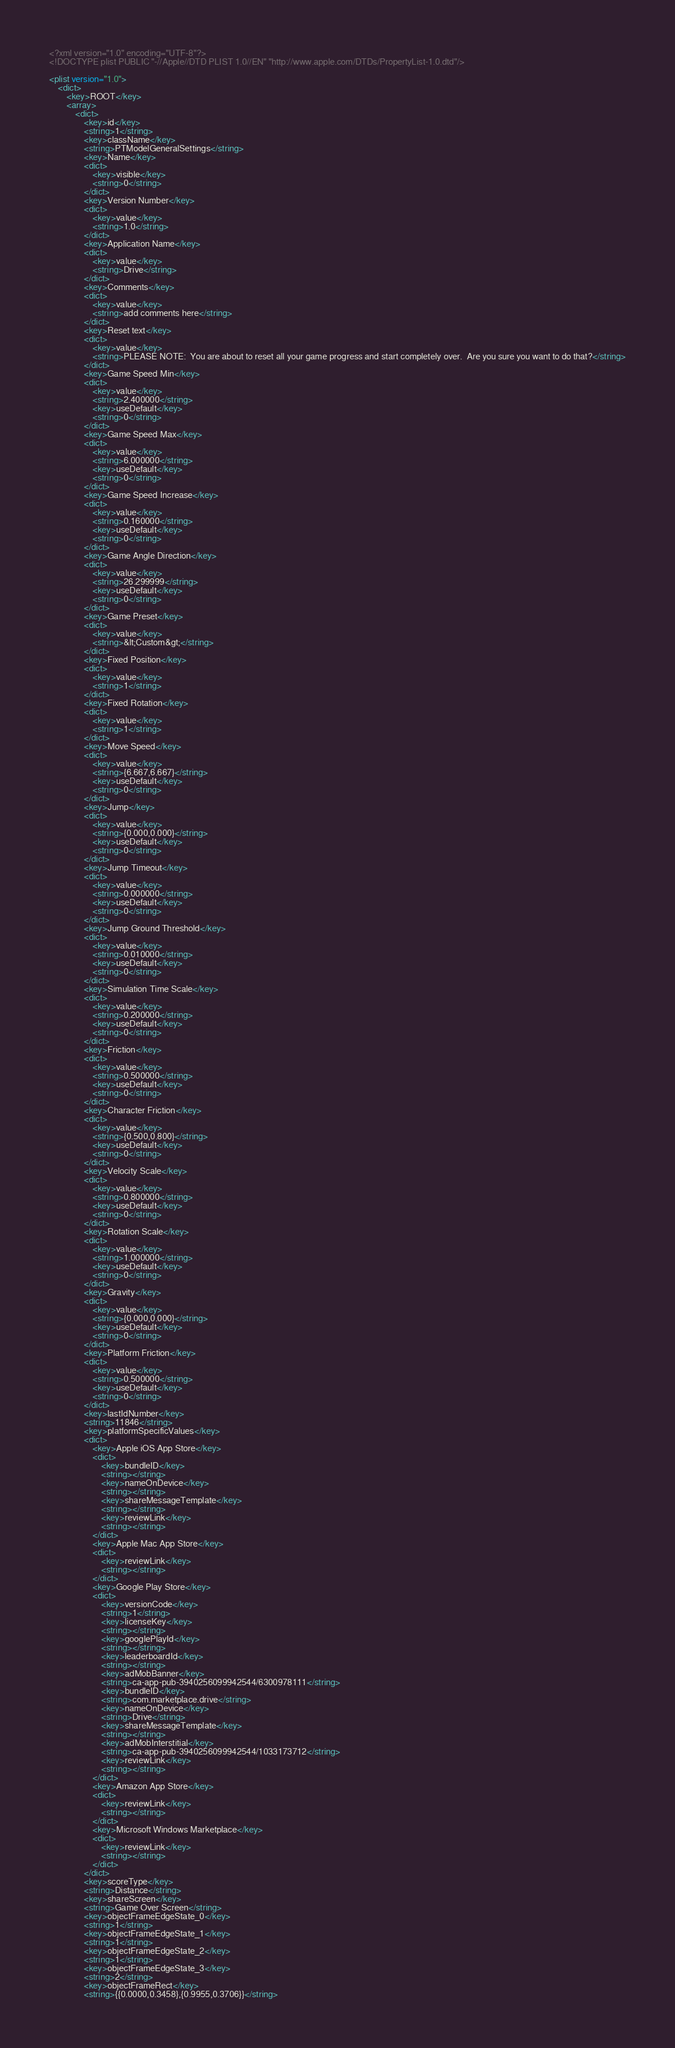Convert code to text. <code><loc_0><loc_0><loc_500><loc_500><_XML_><?xml version="1.0" encoding="UTF-8"?>
<!DOCTYPE plist PUBLIC "-//Apple//DTD PLIST 1.0//EN" "http://www.apple.com/DTDs/PropertyList-1.0.dtd"/>

<plist version="1.0">
    <dict>
        <key>ROOT</key>
        <array>
            <dict>
                <key>id</key>
                <string>1</string>
                <key>className</key>
                <string>PTModelGeneralSettings</string>
                <key>Name</key>
                <dict>
                    <key>visible</key>
                    <string>0</string>
                </dict>
                <key>Version Number</key>
                <dict>
                    <key>value</key>
                    <string>1.0</string>
                </dict>
                <key>Application Name</key>
                <dict>
                    <key>value</key>
                    <string>Drive</string>
                </dict>
                <key>Comments</key>
                <dict>
                    <key>value</key>
                    <string>add comments here</string>
                </dict>
                <key>Reset text</key>
                <dict>
                    <key>value</key>
                    <string>PLEASE NOTE:  You are about to reset all your game progress and start completely over.  Are you sure you want to do that?</string>
                </dict>
                <key>Game Speed Min</key>
                <dict>
                    <key>value</key>
                    <string>2.400000</string>
                    <key>useDefault</key>
                    <string>0</string>
                </dict>
                <key>Game Speed Max</key>
                <dict>
                    <key>value</key>
                    <string>6.000000</string>
                    <key>useDefault</key>
                    <string>0</string>
                </dict>
                <key>Game Speed Increase</key>
                <dict>
                    <key>value</key>
                    <string>0.160000</string>
                    <key>useDefault</key>
                    <string>0</string>
                </dict>
                <key>Game Angle Direction</key>
                <dict>
                    <key>value</key>
                    <string>26.299999</string>
                    <key>useDefault</key>
                    <string>0</string>
                </dict>
                <key>Game Preset</key>
                <dict>
                    <key>value</key>
                    <string>&lt;Custom&gt;</string>
                </dict>
                <key>Fixed Position</key>
                <dict>
                    <key>value</key>
                    <string>1</string>
                </dict>
                <key>Fixed Rotation</key>
                <dict>
                    <key>value</key>
                    <string>1</string>
                </dict>
                <key>Move Speed</key>
                <dict>
                    <key>value</key>
                    <string>{6.667,6.667}</string>
                    <key>useDefault</key>
                    <string>0</string>
                </dict>
                <key>Jump</key>
                <dict>
                    <key>value</key>
                    <string>{0.000,0.000}</string>
                    <key>useDefault</key>
                    <string>0</string>
                </dict>
                <key>Jump Timeout</key>
                <dict>
                    <key>value</key>
                    <string>0.000000</string>
                    <key>useDefault</key>
                    <string>0</string>
                </dict>
                <key>Jump Ground Threshold</key>
                <dict>
                    <key>value</key>
                    <string>0.010000</string>
                    <key>useDefault</key>
                    <string>0</string>
                </dict>
                <key>Simulation Time Scale</key>
                <dict>
                    <key>value</key>
                    <string>0.200000</string>
                    <key>useDefault</key>
                    <string>0</string>
                </dict>
                <key>Friction</key>
                <dict>
                    <key>value</key>
                    <string>0.500000</string>
                    <key>useDefault</key>
                    <string>0</string>
                </dict>
                <key>Character Friction</key>
                <dict>
                    <key>value</key>
                    <string>{0.500,0.800}</string>
                    <key>useDefault</key>
                    <string>0</string>
                </dict>
                <key>Velocity Scale</key>
                <dict>
                    <key>value</key>
                    <string>0.800000</string>
                    <key>useDefault</key>
                    <string>0</string>
                </dict>
                <key>Rotation Scale</key>
                <dict>
                    <key>value</key>
                    <string>1.000000</string>
                    <key>useDefault</key>
                    <string>0</string>
                </dict>
                <key>Gravity</key>
                <dict>
                    <key>value</key>
                    <string>{0.000,0.000}</string>
                    <key>useDefault</key>
                    <string>0</string>
                </dict>
                <key>Platform Friction</key>
                <dict>
                    <key>value</key>
                    <string>0.500000</string>
                    <key>useDefault</key>
                    <string>0</string>
                </dict>
                <key>lastIdNumber</key>
                <string>11846</string>
                <key>platformSpecificValues</key>
                <dict>
                    <key>Apple iOS App Store</key>
                    <dict>
                        <key>bundleID</key>
                        <string></string>
                        <key>nameOnDevice</key>
                        <string></string>
                        <key>shareMessageTemplate</key>
                        <string></string>
                        <key>reviewLink</key>
                        <string></string>
                    </dict>
                    <key>Apple Mac App Store</key>
                    <dict>
                        <key>reviewLink</key>
                        <string></string>
                    </dict>
                    <key>Google Play Store</key>
                    <dict>
                        <key>versionCode</key>
                        <string>1</string>
                        <key>licenseKey</key>
                        <string></string>
                        <key>googlePlayId</key>
                        <string></string>
                        <key>leaderboardId</key>
                        <string></string>
                        <key>adMobBanner</key>
                        <string>ca-app-pub-3940256099942544/6300978111</string>
                        <key>bundleID</key>
                        <string>com.marketplace.drive</string>
                        <key>nameOnDevice</key>
                        <string>Drive</string>
                        <key>shareMessageTemplate</key>
                        <string></string>
                        <key>adMobInterstitial</key>
                        <string>ca-app-pub-3940256099942544/1033173712</string>
                        <key>reviewLink</key>
                        <string></string>
                    </dict>
                    <key>Amazon App Store</key>
                    <dict>
                        <key>reviewLink</key>
                        <string></string>
                    </dict>
                    <key>Microsoft Windows Marketplace</key>
                    <dict>
                        <key>reviewLink</key>
                        <string></string>
                    </dict>
                </dict>
                <key>scoreType</key>
                <string>Distance</string>
                <key>shareScreen</key>
                <string>Game Over Screen</string>
                <key>objectFrameEdgeState_0</key>
                <string>1</string>
                <key>objectFrameEdgeState_1</key>
                <string>1</string>
                <key>objectFrameEdgeState_2</key>
                <string>1</string>
                <key>objectFrameEdgeState_3</key>
                <string>2</string>
                <key>objectFrameRect</key>
                <string>{{0.0000,0.3458},{0.9955,0.3706}}</string></code> 